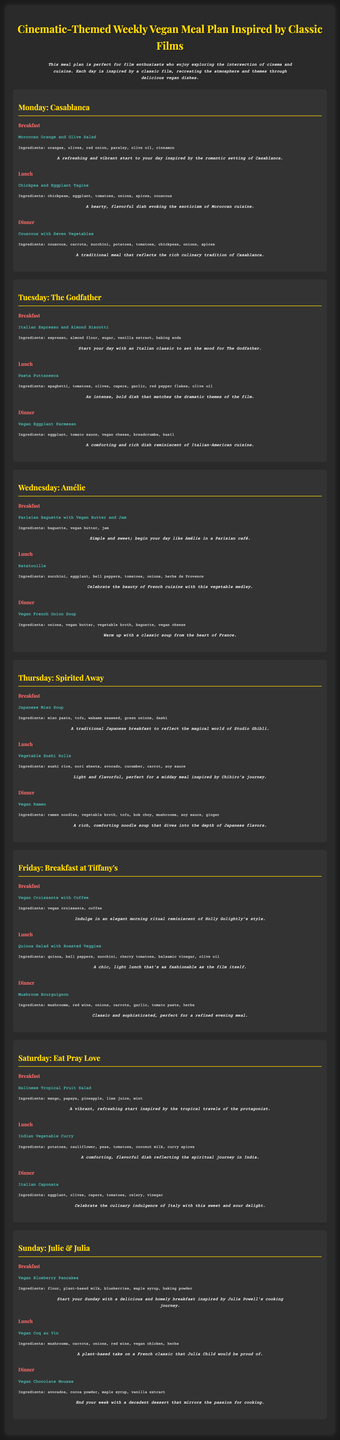What is the title of the meal plan? The title is prominently displayed at the top of the document, which is "Cinematic-Themed Weekly Vegan Meal Plan Inspired by Classic Films."
Answer: Cinematic-Themed Weekly Vegan Meal Plan Inspired by Classic Films How many meals are listed for each day? Each day features three meals: breakfast, lunch, and dinner.
Answer: Three What dish is served for lunch on Thursday? The lunch dish for Thursday is highlighted under the "Thursday: Spirited Away" section.
Answer: Vegetable Sushi Rolls Which film inspired the dinner on Saturday? The dinner for Saturday is associated with the theme of "Eat Pray Love" displayed in the document.
Answer: Eat Pray Love What main ingredient is common in the Tuesday lunch dish? The Tuesday lunch dish's ingredients include spaghetti and other components indicative of its Italian theme.
Answer: Pasta What type of soup is featured for dinner on Wednesday? The Wednesday dinner entry specifically mentions "Vegan French Onion Soup."
Answer: Vegan French Onion Soup What is the main protein used in the breakfast on Thursday? The breakfast for Thursday uses tofu as its main protein source in the miso soup.
Answer: Tofu What cuisine is represented by the dish served on Friday for lunch? The lunch dish for Friday reflects a chic, fashionable style typical of Italian cuisine.
Answer: Italian What is the common theme throughout this meal plan? The overarching theme blends the culinary experience with cinematic references through classic films.
Answer: Classic films 